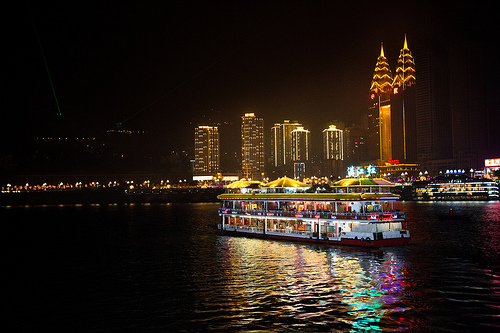Which place is it? This appears to be a vibrant cityscape at night, possibly featuring a famous harbor or riverfront area with illuminated buildings and bustling activity. 